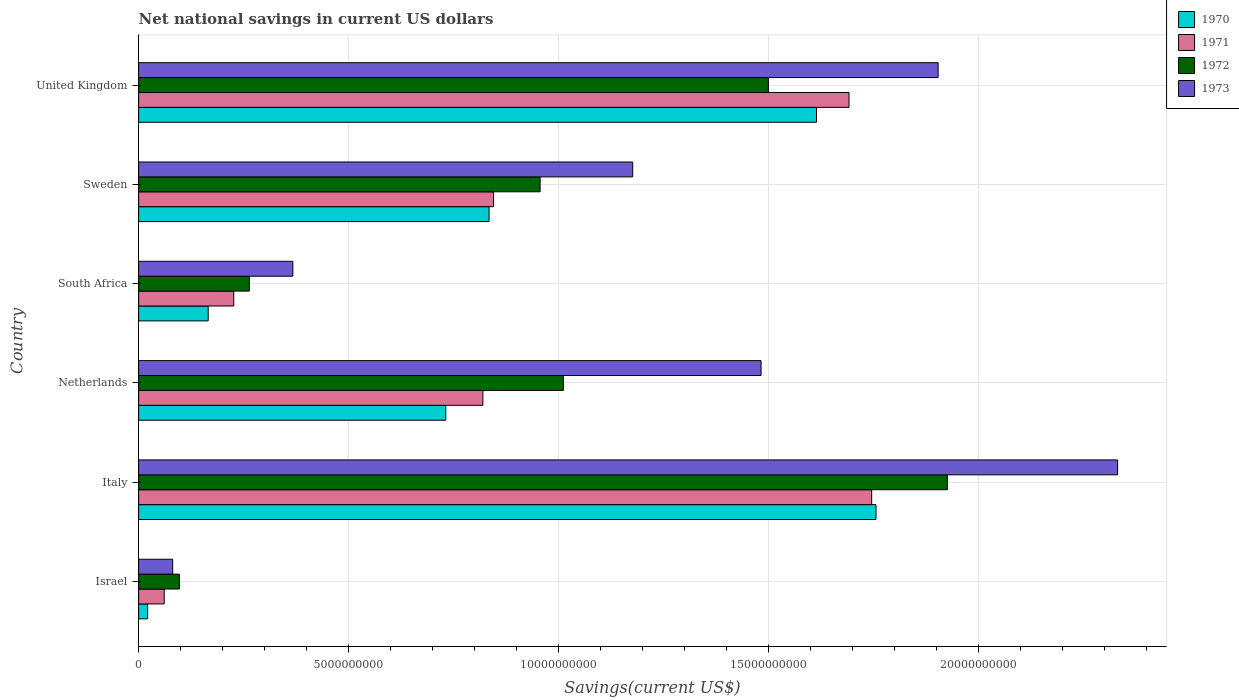How many different coloured bars are there?
Your answer should be compact. 4. How many bars are there on the 1st tick from the bottom?
Provide a short and direct response. 4. In how many cases, is the number of bars for a given country not equal to the number of legend labels?
Offer a terse response. 0. What is the net national savings in 1971 in United Kingdom?
Keep it short and to the point. 1.69e+1. Across all countries, what is the maximum net national savings in 1973?
Make the answer very short. 2.33e+1. Across all countries, what is the minimum net national savings in 1971?
Your answer should be very brief. 6.09e+08. In which country was the net national savings in 1973 maximum?
Your response must be concise. Italy. What is the total net national savings in 1973 in the graph?
Ensure brevity in your answer.  7.34e+1. What is the difference between the net national savings in 1972 in Netherlands and that in United Kingdom?
Keep it short and to the point. -4.88e+09. What is the difference between the net national savings in 1970 in Sweden and the net national savings in 1971 in Israel?
Make the answer very short. 7.73e+09. What is the average net national savings in 1973 per country?
Your answer should be very brief. 1.22e+1. What is the difference between the net national savings in 1972 and net national savings in 1971 in Israel?
Make the answer very short. 3.62e+08. In how many countries, is the net national savings in 1973 greater than 22000000000 US$?
Your answer should be compact. 1. What is the ratio of the net national savings in 1973 in Italy to that in Sweden?
Give a very brief answer. 1.98. Is the net national savings in 1973 in South Africa less than that in United Kingdom?
Provide a succinct answer. Yes. What is the difference between the highest and the second highest net national savings in 1971?
Provide a succinct answer. 5.40e+08. What is the difference between the highest and the lowest net national savings in 1970?
Offer a terse response. 1.73e+1. In how many countries, is the net national savings in 1972 greater than the average net national savings in 1972 taken over all countries?
Provide a short and direct response. 3. What does the 2nd bar from the top in Netherlands represents?
Provide a succinct answer. 1972. What does the 3rd bar from the bottom in Sweden represents?
Give a very brief answer. 1972. How many countries are there in the graph?
Give a very brief answer. 6. What is the difference between two consecutive major ticks on the X-axis?
Make the answer very short. 5.00e+09. Does the graph contain grids?
Make the answer very short. Yes. How are the legend labels stacked?
Keep it short and to the point. Vertical. What is the title of the graph?
Ensure brevity in your answer.  Net national savings in current US dollars. What is the label or title of the X-axis?
Offer a terse response. Savings(current US$). What is the label or title of the Y-axis?
Provide a succinct answer. Country. What is the Savings(current US$) in 1970 in Israel?
Keep it short and to the point. 2.15e+08. What is the Savings(current US$) of 1971 in Israel?
Provide a succinct answer. 6.09e+08. What is the Savings(current US$) of 1972 in Israel?
Give a very brief answer. 9.71e+08. What is the Savings(current US$) in 1973 in Israel?
Your answer should be compact. 8.11e+08. What is the Savings(current US$) in 1970 in Italy?
Provide a short and direct response. 1.76e+1. What is the Savings(current US$) of 1971 in Italy?
Keep it short and to the point. 1.75e+1. What is the Savings(current US$) in 1972 in Italy?
Give a very brief answer. 1.93e+1. What is the Savings(current US$) in 1973 in Italy?
Give a very brief answer. 2.33e+1. What is the Savings(current US$) in 1970 in Netherlands?
Make the answer very short. 7.31e+09. What is the Savings(current US$) of 1971 in Netherlands?
Make the answer very short. 8.20e+09. What is the Savings(current US$) in 1972 in Netherlands?
Provide a succinct answer. 1.01e+1. What is the Savings(current US$) in 1973 in Netherlands?
Provide a short and direct response. 1.48e+1. What is the Savings(current US$) in 1970 in South Africa?
Your response must be concise. 1.66e+09. What is the Savings(current US$) in 1971 in South Africa?
Offer a terse response. 2.27e+09. What is the Savings(current US$) in 1972 in South Africa?
Provide a short and direct response. 2.64e+09. What is the Savings(current US$) in 1973 in South Africa?
Offer a very short reply. 3.67e+09. What is the Savings(current US$) of 1970 in Sweden?
Ensure brevity in your answer.  8.34e+09. What is the Savings(current US$) in 1971 in Sweden?
Keep it short and to the point. 8.45e+09. What is the Savings(current US$) in 1972 in Sweden?
Offer a terse response. 9.56e+09. What is the Savings(current US$) of 1973 in Sweden?
Your answer should be compact. 1.18e+1. What is the Savings(current US$) of 1970 in United Kingdom?
Provide a succinct answer. 1.61e+1. What is the Savings(current US$) of 1971 in United Kingdom?
Provide a short and direct response. 1.69e+1. What is the Savings(current US$) of 1972 in United Kingdom?
Provide a short and direct response. 1.50e+1. What is the Savings(current US$) in 1973 in United Kingdom?
Your answer should be very brief. 1.90e+1. Across all countries, what is the maximum Savings(current US$) of 1970?
Ensure brevity in your answer.  1.76e+1. Across all countries, what is the maximum Savings(current US$) in 1971?
Your answer should be compact. 1.75e+1. Across all countries, what is the maximum Savings(current US$) of 1972?
Keep it short and to the point. 1.93e+1. Across all countries, what is the maximum Savings(current US$) in 1973?
Keep it short and to the point. 2.33e+1. Across all countries, what is the minimum Savings(current US$) in 1970?
Offer a very short reply. 2.15e+08. Across all countries, what is the minimum Savings(current US$) in 1971?
Ensure brevity in your answer.  6.09e+08. Across all countries, what is the minimum Savings(current US$) of 1972?
Your response must be concise. 9.71e+08. Across all countries, what is the minimum Savings(current US$) of 1973?
Provide a succinct answer. 8.11e+08. What is the total Savings(current US$) of 1970 in the graph?
Provide a short and direct response. 5.12e+1. What is the total Savings(current US$) in 1971 in the graph?
Make the answer very short. 5.39e+1. What is the total Savings(current US$) of 1972 in the graph?
Your response must be concise. 5.75e+1. What is the total Savings(current US$) in 1973 in the graph?
Keep it short and to the point. 7.34e+1. What is the difference between the Savings(current US$) in 1970 in Israel and that in Italy?
Your answer should be very brief. -1.73e+1. What is the difference between the Savings(current US$) in 1971 in Israel and that in Italy?
Keep it short and to the point. -1.68e+1. What is the difference between the Savings(current US$) in 1972 in Israel and that in Italy?
Your answer should be compact. -1.83e+1. What is the difference between the Savings(current US$) of 1973 in Israel and that in Italy?
Provide a succinct answer. -2.25e+1. What is the difference between the Savings(current US$) in 1970 in Israel and that in Netherlands?
Ensure brevity in your answer.  -7.10e+09. What is the difference between the Savings(current US$) in 1971 in Israel and that in Netherlands?
Give a very brief answer. -7.59e+09. What is the difference between the Savings(current US$) in 1972 in Israel and that in Netherlands?
Your answer should be compact. -9.14e+09. What is the difference between the Savings(current US$) of 1973 in Israel and that in Netherlands?
Your answer should be compact. -1.40e+1. What is the difference between the Savings(current US$) of 1970 in Israel and that in South Africa?
Provide a short and direct response. -1.44e+09. What is the difference between the Savings(current US$) in 1971 in Israel and that in South Africa?
Provide a short and direct response. -1.66e+09. What is the difference between the Savings(current US$) of 1972 in Israel and that in South Africa?
Provide a succinct answer. -1.66e+09. What is the difference between the Savings(current US$) in 1973 in Israel and that in South Africa?
Your response must be concise. -2.86e+09. What is the difference between the Savings(current US$) in 1970 in Israel and that in Sweden?
Your answer should be very brief. -8.13e+09. What is the difference between the Savings(current US$) in 1971 in Israel and that in Sweden?
Your answer should be very brief. -7.84e+09. What is the difference between the Savings(current US$) of 1972 in Israel and that in Sweden?
Provide a short and direct response. -8.59e+09. What is the difference between the Savings(current US$) of 1973 in Israel and that in Sweden?
Your response must be concise. -1.10e+1. What is the difference between the Savings(current US$) in 1970 in Israel and that in United Kingdom?
Offer a terse response. -1.59e+1. What is the difference between the Savings(current US$) in 1971 in Israel and that in United Kingdom?
Ensure brevity in your answer.  -1.63e+1. What is the difference between the Savings(current US$) in 1972 in Israel and that in United Kingdom?
Offer a very short reply. -1.40e+1. What is the difference between the Savings(current US$) in 1973 in Israel and that in United Kingdom?
Offer a terse response. -1.82e+1. What is the difference between the Savings(current US$) in 1970 in Italy and that in Netherlands?
Provide a succinct answer. 1.02e+1. What is the difference between the Savings(current US$) of 1971 in Italy and that in Netherlands?
Your response must be concise. 9.26e+09. What is the difference between the Savings(current US$) in 1972 in Italy and that in Netherlands?
Provide a short and direct response. 9.14e+09. What is the difference between the Savings(current US$) in 1973 in Italy and that in Netherlands?
Keep it short and to the point. 8.49e+09. What is the difference between the Savings(current US$) of 1970 in Italy and that in South Africa?
Your answer should be very brief. 1.59e+1. What is the difference between the Savings(current US$) of 1971 in Italy and that in South Africa?
Your response must be concise. 1.52e+1. What is the difference between the Savings(current US$) of 1972 in Italy and that in South Africa?
Ensure brevity in your answer.  1.66e+1. What is the difference between the Savings(current US$) in 1973 in Italy and that in South Africa?
Give a very brief answer. 1.96e+1. What is the difference between the Savings(current US$) of 1970 in Italy and that in Sweden?
Give a very brief answer. 9.21e+09. What is the difference between the Savings(current US$) of 1971 in Italy and that in Sweden?
Make the answer very short. 9.00e+09. What is the difference between the Savings(current US$) in 1972 in Italy and that in Sweden?
Give a very brief answer. 9.70e+09. What is the difference between the Savings(current US$) of 1973 in Italy and that in Sweden?
Offer a terse response. 1.15e+1. What is the difference between the Savings(current US$) in 1970 in Italy and that in United Kingdom?
Keep it short and to the point. 1.42e+09. What is the difference between the Savings(current US$) in 1971 in Italy and that in United Kingdom?
Your response must be concise. 5.40e+08. What is the difference between the Savings(current US$) in 1972 in Italy and that in United Kingdom?
Make the answer very short. 4.26e+09. What is the difference between the Savings(current US$) of 1973 in Italy and that in United Kingdom?
Your response must be concise. 4.27e+09. What is the difference between the Savings(current US$) of 1970 in Netherlands and that in South Africa?
Keep it short and to the point. 5.66e+09. What is the difference between the Savings(current US$) of 1971 in Netherlands and that in South Africa?
Keep it short and to the point. 5.93e+09. What is the difference between the Savings(current US$) of 1972 in Netherlands and that in South Africa?
Give a very brief answer. 7.48e+09. What is the difference between the Savings(current US$) in 1973 in Netherlands and that in South Africa?
Your response must be concise. 1.11e+1. What is the difference between the Savings(current US$) in 1970 in Netherlands and that in Sweden?
Your answer should be very brief. -1.03e+09. What is the difference between the Savings(current US$) in 1971 in Netherlands and that in Sweden?
Give a very brief answer. -2.53e+08. What is the difference between the Savings(current US$) in 1972 in Netherlands and that in Sweden?
Your answer should be compact. 5.54e+08. What is the difference between the Savings(current US$) of 1973 in Netherlands and that in Sweden?
Provide a succinct answer. 3.06e+09. What is the difference between the Savings(current US$) in 1970 in Netherlands and that in United Kingdom?
Your answer should be compact. -8.83e+09. What is the difference between the Savings(current US$) of 1971 in Netherlands and that in United Kingdom?
Provide a succinct answer. -8.72e+09. What is the difference between the Savings(current US$) in 1972 in Netherlands and that in United Kingdom?
Provide a short and direct response. -4.88e+09. What is the difference between the Savings(current US$) in 1973 in Netherlands and that in United Kingdom?
Ensure brevity in your answer.  -4.22e+09. What is the difference between the Savings(current US$) in 1970 in South Africa and that in Sweden?
Offer a terse response. -6.69e+09. What is the difference between the Savings(current US$) of 1971 in South Africa and that in Sweden?
Give a very brief answer. -6.18e+09. What is the difference between the Savings(current US$) in 1972 in South Africa and that in Sweden?
Keep it short and to the point. -6.92e+09. What is the difference between the Savings(current US$) in 1973 in South Africa and that in Sweden?
Ensure brevity in your answer.  -8.09e+09. What is the difference between the Savings(current US$) of 1970 in South Africa and that in United Kingdom?
Ensure brevity in your answer.  -1.45e+1. What is the difference between the Savings(current US$) of 1971 in South Africa and that in United Kingdom?
Offer a very short reply. -1.46e+1. What is the difference between the Savings(current US$) in 1972 in South Africa and that in United Kingdom?
Provide a short and direct response. -1.24e+1. What is the difference between the Savings(current US$) in 1973 in South Africa and that in United Kingdom?
Make the answer very short. -1.54e+1. What is the difference between the Savings(current US$) in 1970 in Sweden and that in United Kingdom?
Provide a short and direct response. -7.80e+09. What is the difference between the Savings(current US$) of 1971 in Sweden and that in United Kingdom?
Keep it short and to the point. -8.46e+09. What is the difference between the Savings(current US$) in 1972 in Sweden and that in United Kingdom?
Your answer should be compact. -5.43e+09. What is the difference between the Savings(current US$) of 1973 in Sweden and that in United Kingdom?
Your response must be concise. -7.27e+09. What is the difference between the Savings(current US$) in 1970 in Israel and the Savings(current US$) in 1971 in Italy?
Your response must be concise. -1.72e+1. What is the difference between the Savings(current US$) in 1970 in Israel and the Savings(current US$) in 1972 in Italy?
Your answer should be compact. -1.90e+1. What is the difference between the Savings(current US$) in 1970 in Israel and the Savings(current US$) in 1973 in Italy?
Your answer should be very brief. -2.31e+1. What is the difference between the Savings(current US$) of 1971 in Israel and the Savings(current US$) of 1972 in Italy?
Provide a short and direct response. -1.86e+1. What is the difference between the Savings(current US$) of 1971 in Israel and the Savings(current US$) of 1973 in Italy?
Give a very brief answer. -2.27e+1. What is the difference between the Savings(current US$) of 1972 in Israel and the Savings(current US$) of 1973 in Italy?
Keep it short and to the point. -2.23e+1. What is the difference between the Savings(current US$) of 1970 in Israel and the Savings(current US$) of 1971 in Netherlands?
Make the answer very short. -7.98e+09. What is the difference between the Savings(current US$) in 1970 in Israel and the Savings(current US$) in 1972 in Netherlands?
Provide a succinct answer. -9.90e+09. What is the difference between the Savings(current US$) in 1970 in Israel and the Savings(current US$) in 1973 in Netherlands?
Offer a terse response. -1.46e+1. What is the difference between the Savings(current US$) of 1971 in Israel and the Savings(current US$) of 1972 in Netherlands?
Your response must be concise. -9.50e+09. What is the difference between the Savings(current US$) in 1971 in Israel and the Savings(current US$) in 1973 in Netherlands?
Give a very brief answer. -1.42e+1. What is the difference between the Savings(current US$) of 1972 in Israel and the Savings(current US$) of 1973 in Netherlands?
Offer a very short reply. -1.38e+1. What is the difference between the Savings(current US$) in 1970 in Israel and the Savings(current US$) in 1971 in South Africa?
Keep it short and to the point. -2.05e+09. What is the difference between the Savings(current US$) of 1970 in Israel and the Savings(current US$) of 1972 in South Africa?
Your answer should be very brief. -2.42e+09. What is the difference between the Savings(current US$) of 1970 in Israel and the Savings(current US$) of 1973 in South Africa?
Provide a succinct answer. -3.46e+09. What is the difference between the Savings(current US$) of 1971 in Israel and the Savings(current US$) of 1972 in South Africa?
Ensure brevity in your answer.  -2.03e+09. What is the difference between the Savings(current US$) in 1971 in Israel and the Savings(current US$) in 1973 in South Africa?
Your response must be concise. -3.06e+09. What is the difference between the Savings(current US$) of 1972 in Israel and the Savings(current US$) of 1973 in South Africa?
Your answer should be very brief. -2.70e+09. What is the difference between the Savings(current US$) of 1970 in Israel and the Savings(current US$) of 1971 in Sweden?
Give a very brief answer. -8.23e+09. What is the difference between the Savings(current US$) in 1970 in Israel and the Savings(current US$) in 1972 in Sweden?
Make the answer very short. -9.34e+09. What is the difference between the Savings(current US$) of 1970 in Israel and the Savings(current US$) of 1973 in Sweden?
Provide a short and direct response. -1.15e+1. What is the difference between the Savings(current US$) in 1971 in Israel and the Savings(current US$) in 1972 in Sweden?
Offer a very short reply. -8.95e+09. What is the difference between the Savings(current US$) in 1971 in Israel and the Savings(current US$) in 1973 in Sweden?
Give a very brief answer. -1.12e+1. What is the difference between the Savings(current US$) in 1972 in Israel and the Savings(current US$) in 1973 in Sweden?
Give a very brief answer. -1.08e+1. What is the difference between the Savings(current US$) of 1970 in Israel and the Savings(current US$) of 1971 in United Kingdom?
Provide a short and direct response. -1.67e+1. What is the difference between the Savings(current US$) of 1970 in Israel and the Savings(current US$) of 1972 in United Kingdom?
Give a very brief answer. -1.48e+1. What is the difference between the Savings(current US$) of 1970 in Israel and the Savings(current US$) of 1973 in United Kingdom?
Make the answer very short. -1.88e+1. What is the difference between the Savings(current US$) of 1971 in Israel and the Savings(current US$) of 1972 in United Kingdom?
Make the answer very short. -1.44e+1. What is the difference between the Savings(current US$) of 1971 in Israel and the Savings(current US$) of 1973 in United Kingdom?
Your answer should be compact. -1.84e+1. What is the difference between the Savings(current US$) of 1972 in Israel and the Savings(current US$) of 1973 in United Kingdom?
Keep it short and to the point. -1.81e+1. What is the difference between the Savings(current US$) of 1970 in Italy and the Savings(current US$) of 1971 in Netherlands?
Keep it short and to the point. 9.36e+09. What is the difference between the Savings(current US$) of 1970 in Italy and the Savings(current US$) of 1972 in Netherlands?
Your answer should be very brief. 7.44e+09. What is the difference between the Savings(current US$) of 1970 in Italy and the Savings(current US$) of 1973 in Netherlands?
Ensure brevity in your answer.  2.74e+09. What is the difference between the Savings(current US$) of 1971 in Italy and the Savings(current US$) of 1972 in Netherlands?
Make the answer very short. 7.34e+09. What is the difference between the Savings(current US$) of 1971 in Italy and the Savings(current US$) of 1973 in Netherlands?
Keep it short and to the point. 2.63e+09. What is the difference between the Savings(current US$) of 1972 in Italy and the Savings(current US$) of 1973 in Netherlands?
Make the answer very short. 4.44e+09. What is the difference between the Savings(current US$) of 1970 in Italy and the Savings(current US$) of 1971 in South Africa?
Give a very brief answer. 1.53e+1. What is the difference between the Savings(current US$) of 1970 in Italy and the Savings(current US$) of 1972 in South Africa?
Keep it short and to the point. 1.49e+1. What is the difference between the Savings(current US$) of 1970 in Italy and the Savings(current US$) of 1973 in South Africa?
Give a very brief answer. 1.39e+1. What is the difference between the Savings(current US$) in 1971 in Italy and the Savings(current US$) in 1972 in South Africa?
Offer a terse response. 1.48e+1. What is the difference between the Savings(current US$) in 1971 in Italy and the Savings(current US$) in 1973 in South Africa?
Your answer should be compact. 1.38e+1. What is the difference between the Savings(current US$) of 1972 in Italy and the Savings(current US$) of 1973 in South Africa?
Provide a succinct answer. 1.56e+1. What is the difference between the Savings(current US$) of 1970 in Italy and the Savings(current US$) of 1971 in Sweden?
Give a very brief answer. 9.11e+09. What is the difference between the Savings(current US$) of 1970 in Italy and the Savings(current US$) of 1972 in Sweden?
Make the answer very short. 8.00e+09. What is the difference between the Savings(current US$) of 1970 in Italy and the Savings(current US$) of 1973 in Sweden?
Keep it short and to the point. 5.79e+09. What is the difference between the Savings(current US$) in 1971 in Italy and the Savings(current US$) in 1972 in Sweden?
Your answer should be compact. 7.89e+09. What is the difference between the Savings(current US$) of 1971 in Italy and the Savings(current US$) of 1973 in Sweden?
Your answer should be compact. 5.69e+09. What is the difference between the Savings(current US$) of 1972 in Italy and the Savings(current US$) of 1973 in Sweden?
Offer a very short reply. 7.49e+09. What is the difference between the Savings(current US$) in 1970 in Italy and the Savings(current US$) in 1971 in United Kingdom?
Offer a very short reply. 6.43e+08. What is the difference between the Savings(current US$) in 1970 in Italy and the Savings(current US$) in 1972 in United Kingdom?
Offer a very short reply. 2.56e+09. What is the difference between the Savings(current US$) of 1970 in Italy and the Savings(current US$) of 1973 in United Kingdom?
Provide a short and direct response. -1.48e+09. What is the difference between the Savings(current US$) in 1971 in Italy and the Savings(current US$) in 1972 in United Kingdom?
Offer a terse response. 2.46e+09. What is the difference between the Savings(current US$) in 1971 in Italy and the Savings(current US$) in 1973 in United Kingdom?
Your answer should be compact. -1.58e+09. What is the difference between the Savings(current US$) of 1972 in Italy and the Savings(current US$) of 1973 in United Kingdom?
Ensure brevity in your answer.  2.20e+08. What is the difference between the Savings(current US$) in 1970 in Netherlands and the Savings(current US$) in 1971 in South Africa?
Your answer should be compact. 5.05e+09. What is the difference between the Savings(current US$) in 1970 in Netherlands and the Savings(current US$) in 1972 in South Africa?
Ensure brevity in your answer.  4.68e+09. What is the difference between the Savings(current US$) of 1970 in Netherlands and the Savings(current US$) of 1973 in South Africa?
Keep it short and to the point. 3.64e+09. What is the difference between the Savings(current US$) of 1971 in Netherlands and the Savings(current US$) of 1972 in South Africa?
Provide a succinct answer. 5.56e+09. What is the difference between the Savings(current US$) of 1971 in Netherlands and the Savings(current US$) of 1973 in South Africa?
Give a very brief answer. 4.52e+09. What is the difference between the Savings(current US$) of 1972 in Netherlands and the Savings(current US$) of 1973 in South Africa?
Your answer should be very brief. 6.44e+09. What is the difference between the Savings(current US$) in 1970 in Netherlands and the Savings(current US$) in 1971 in Sweden?
Keep it short and to the point. -1.14e+09. What is the difference between the Savings(current US$) of 1970 in Netherlands and the Savings(current US$) of 1972 in Sweden?
Your response must be concise. -2.25e+09. What is the difference between the Savings(current US$) in 1970 in Netherlands and the Savings(current US$) in 1973 in Sweden?
Provide a succinct answer. -4.45e+09. What is the difference between the Savings(current US$) of 1971 in Netherlands and the Savings(current US$) of 1972 in Sweden?
Give a very brief answer. -1.36e+09. What is the difference between the Savings(current US$) in 1971 in Netherlands and the Savings(current US$) in 1973 in Sweden?
Give a very brief answer. -3.57e+09. What is the difference between the Savings(current US$) of 1972 in Netherlands and the Savings(current US$) of 1973 in Sweden?
Give a very brief answer. -1.65e+09. What is the difference between the Savings(current US$) in 1970 in Netherlands and the Savings(current US$) in 1971 in United Kingdom?
Your answer should be compact. -9.60e+09. What is the difference between the Savings(current US$) in 1970 in Netherlands and the Savings(current US$) in 1972 in United Kingdom?
Ensure brevity in your answer.  -7.68e+09. What is the difference between the Savings(current US$) in 1970 in Netherlands and the Savings(current US$) in 1973 in United Kingdom?
Provide a short and direct response. -1.17e+1. What is the difference between the Savings(current US$) in 1971 in Netherlands and the Savings(current US$) in 1972 in United Kingdom?
Offer a very short reply. -6.80e+09. What is the difference between the Savings(current US$) of 1971 in Netherlands and the Savings(current US$) of 1973 in United Kingdom?
Provide a short and direct response. -1.08e+1. What is the difference between the Savings(current US$) of 1972 in Netherlands and the Savings(current US$) of 1973 in United Kingdom?
Ensure brevity in your answer.  -8.92e+09. What is the difference between the Savings(current US$) in 1970 in South Africa and the Savings(current US$) in 1971 in Sweden?
Give a very brief answer. -6.79e+09. What is the difference between the Savings(current US$) in 1970 in South Africa and the Savings(current US$) in 1972 in Sweden?
Give a very brief answer. -7.90e+09. What is the difference between the Savings(current US$) of 1970 in South Africa and the Savings(current US$) of 1973 in Sweden?
Your answer should be very brief. -1.01e+1. What is the difference between the Savings(current US$) in 1971 in South Africa and the Savings(current US$) in 1972 in Sweden?
Offer a very short reply. -7.29e+09. What is the difference between the Savings(current US$) of 1971 in South Africa and the Savings(current US$) of 1973 in Sweden?
Provide a short and direct response. -9.50e+09. What is the difference between the Savings(current US$) of 1972 in South Africa and the Savings(current US$) of 1973 in Sweden?
Your answer should be compact. -9.13e+09. What is the difference between the Savings(current US$) in 1970 in South Africa and the Savings(current US$) in 1971 in United Kingdom?
Offer a terse response. -1.53e+1. What is the difference between the Savings(current US$) in 1970 in South Africa and the Savings(current US$) in 1972 in United Kingdom?
Provide a short and direct response. -1.33e+1. What is the difference between the Savings(current US$) in 1970 in South Africa and the Savings(current US$) in 1973 in United Kingdom?
Make the answer very short. -1.74e+1. What is the difference between the Savings(current US$) of 1971 in South Africa and the Savings(current US$) of 1972 in United Kingdom?
Offer a very short reply. -1.27e+1. What is the difference between the Savings(current US$) of 1971 in South Africa and the Savings(current US$) of 1973 in United Kingdom?
Offer a very short reply. -1.68e+1. What is the difference between the Savings(current US$) of 1972 in South Africa and the Savings(current US$) of 1973 in United Kingdom?
Provide a succinct answer. -1.64e+1. What is the difference between the Savings(current US$) in 1970 in Sweden and the Savings(current US$) in 1971 in United Kingdom?
Provide a succinct answer. -8.57e+09. What is the difference between the Savings(current US$) in 1970 in Sweden and the Savings(current US$) in 1972 in United Kingdom?
Your response must be concise. -6.65e+09. What is the difference between the Savings(current US$) of 1970 in Sweden and the Savings(current US$) of 1973 in United Kingdom?
Provide a succinct answer. -1.07e+1. What is the difference between the Savings(current US$) of 1971 in Sweden and the Savings(current US$) of 1972 in United Kingdom?
Ensure brevity in your answer.  -6.54e+09. What is the difference between the Savings(current US$) in 1971 in Sweden and the Savings(current US$) in 1973 in United Kingdom?
Ensure brevity in your answer.  -1.06e+1. What is the difference between the Savings(current US$) in 1972 in Sweden and the Savings(current US$) in 1973 in United Kingdom?
Offer a terse response. -9.48e+09. What is the average Savings(current US$) in 1970 per country?
Offer a very short reply. 8.54e+09. What is the average Savings(current US$) of 1971 per country?
Your response must be concise. 8.98e+09. What is the average Savings(current US$) of 1972 per country?
Give a very brief answer. 9.59e+09. What is the average Savings(current US$) of 1973 per country?
Make the answer very short. 1.22e+1. What is the difference between the Savings(current US$) of 1970 and Savings(current US$) of 1971 in Israel?
Your answer should be very brief. -3.94e+08. What is the difference between the Savings(current US$) of 1970 and Savings(current US$) of 1972 in Israel?
Keep it short and to the point. -7.56e+08. What is the difference between the Savings(current US$) of 1970 and Savings(current US$) of 1973 in Israel?
Make the answer very short. -5.96e+08. What is the difference between the Savings(current US$) in 1971 and Savings(current US$) in 1972 in Israel?
Make the answer very short. -3.62e+08. What is the difference between the Savings(current US$) of 1971 and Savings(current US$) of 1973 in Israel?
Give a very brief answer. -2.02e+08. What is the difference between the Savings(current US$) in 1972 and Savings(current US$) in 1973 in Israel?
Your response must be concise. 1.60e+08. What is the difference between the Savings(current US$) of 1970 and Savings(current US$) of 1971 in Italy?
Offer a very short reply. 1.03e+08. What is the difference between the Savings(current US$) of 1970 and Savings(current US$) of 1972 in Italy?
Provide a succinct answer. -1.70e+09. What is the difference between the Savings(current US$) of 1970 and Savings(current US$) of 1973 in Italy?
Offer a terse response. -5.75e+09. What is the difference between the Savings(current US$) in 1971 and Savings(current US$) in 1972 in Italy?
Make the answer very short. -1.80e+09. What is the difference between the Savings(current US$) of 1971 and Savings(current US$) of 1973 in Italy?
Ensure brevity in your answer.  -5.86e+09. What is the difference between the Savings(current US$) in 1972 and Savings(current US$) in 1973 in Italy?
Your answer should be very brief. -4.05e+09. What is the difference between the Savings(current US$) of 1970 and Savings(current US$) of 1971 in Netherlands?
Make the answer very short. -8.83e+08. What is the difference between the Savings(current US$) in 1970 and Savings(current US$) in 1972 in Netherlands?
Offer a terse response. -2.80e+09. What is the difference between the Savings(current US$) in 1970 and Savings(current US$) in 1973 in Netherlands?
Offer a very short reply. -7.51e+09. What is the difference between the Savings(current US$) of 1971 and Savings(current US$) of 1972 in Netherlands?
Offer a terse response. -1.92e+09. What is the difference between the Savings(current US$) of 1971 and Savings(current US$) of 1973 in Netherlands?
Keep it short and to the point. -6.62e+09. What is the difference between the Savings(current US$) of 1972 and Savings(current US$) of 1973 in Netherlands?
Ensure brevity in your answer.  -4.71e+09. What is the difference between the Savings(current US$) in 1970 and Savings(current US$) in 1971 in South Africa?
Keep it short and to the point. -6.09e+08. What is the difference between the Savings(current US$) of 1970 and Savings(current US$) of 1972 in South Africa?
Keep it short and to the point. -9.79e+08. What is the difference between the Savings(current US$) of 1970 and Savings(current US$) of 1973 in South Africa?
Provide a short and direct response. -2.02e+09. What is the difference between the Savings(current US$) of 1971 and Savings(current US$) of 1972 in South Africa?
Your response must be concise. -3.70e+08. What is the difference between the Savings(current US$) of 1971 and Savings(current US$) of 1973 in South Africa?
Keep it short and to the point. -1.41e+09. What is the difference between the Savings(current US$) of 1972 and Savings(current US$) of 1973 in South Africa?
Provide a succinct answer. -1.04e+09. What is the difference between the Savings(current US$) in 1970 and Savings(current US$) in 1971 in Sweden?
Ensure brevity in your answer.  -1.07e+08. What is the difference between the Savings(current US$) in 1970 and Savings(current US$) in 1972 in Sweden?
Offer a very short reply. -1.22e+09. What is the difference between the Savings(current US$) of 1970 and Savings(current US$) of 1973 in Sweden?
Ensure brevity in your answer.  -3.42e+09. What is the difference between the Savings(current US$) of 1971 and Savings(current US$) of 1972 in Sweden?
Provide a succinct answer. -1.11e+09. What is the difference between the Savings(current US$) in 1971 and Savings(current US$) in 1973 in Sweden?
Your answer should be compact. -3.31e+09. What is the difference between the Savings(current US$) of 1972 and Savings(current US$) of 1973 in Sweden?
Give a very brief answer. -2.20e+09. What is the difference between the Savings(current US$) of 1970 and Savings(current US$) of 1971 in United Kingdom?
Offer a very short reply. -7.74e+08. What is the difference between the Savings(current US$) in 1970 and Savings(current US$) in 1972 in United Kingdom?
Provide a succinct answer. 1.15e+09. What is the difference between the Savings(current US$) of 1970 and Savings(current US$) of 1973 in United Kingdom?
Offer a very short reply. -2.90e+09. What is the difference between the Savings(current US$) of 1971 and Savings(current US$) of 1972 in United Kingdom?
Offer a very short reply. 1.92e+09. What is the difference between the Savings(current US$) in 1971 and Savings(current US$) in 1973 in United Kingdom?
Provide a short and direct response. -2.12e+09. What is the difference between the Savings(current US$) in 1972 and Savings(current US$) in 1973 in United Kingdom?
Offer a very short reply. -4.04e+09. What is the ratio of the Savings(current US$) in 1970 in Israel to that in Italy?
Make the answer very short. 0.01. What is the ratio of the Savings(current US$) of 1971 in Israel to that in Italy?
Your response must be concise. 0.03. What is the ratio of the Savings(current US$) of 1972 in Israel to that in Italy?
Ensure brevity in your answer.  0.05. What is the ratio of the Savings(current US$) of 1973 in Israel to that in Italy?
Provide a short and direct response. 0.03. What is the ratio of the Savings(current US$) in 1970 in Israel to that in Netherlands?
Offer a terse response. 0.03. What is the ratio of the Savings(current US$) of 1971 in Israel to that in Netherlands?
Keep it short and to the point. 0.07. What is the ratio of the Savings(current US$) of 1972 in Israel to that in Netherlands?
Make the answer very short. 0.1. What is the ratio of the Savings(current US$) in 1973 in Israel to that in Netherlands?
Your response must be concise. 0.05. What is the ratio of the Savings(current US$) in 1970 in Israel to that in South Africa?
Your response must be concise. 0.13. What is the ratio of the Savings(current US$) in 1971 in Israel to that in South Africa?
Provide a succinct answer. 0.27. What is the ratio of the Savings(current US$) in 1972 in Israel to that in South Africa?
Offer a very short reply. 0.37. What is the ratio of the Savings(current US$) in 1973 in Israel to that in South Africa?
Your answer should be compact. 0.22. What is the ratio of the Savings(current US$) in 1970 in Israel to that in Sweden?
Your answer should be very brief. 0.03. What is the ratio of the Savings(current US$) of 1971 in Israel to that in Sweden?
Your answer should be very brief. 0.07. What is the ratio of the Savings(current US$) in 1972 in Israel to that in Sweden?
Offer a terse response. 0.1. What is the ratio of the Savings(current US$) of 1973 in Israel to that in Sweden?
Keep it short and to the point. 0.07. What is the ratio of the Savings(current US$) in 1970 in Israel to that in United Kingdom?
Give a very brief answer. 0.01. What is the ratio of the Savings(current US$) of 1971 in Israel to that in United Kingdom?
Offer a very short reply. 0.04. What is the ratio of the Savings(current US$) in 1972 in Israel to that in United Kingdom?
Your answer should be very brief. 0.06. What is the ratio of the Savings(current US$) in 1973 in Israel to that in United Kingdom?
Make the answer very short. 0.04. What is the ratio of the Savings(current US$) of 1970 in Italy to that in Netherlands?
Your answer should be compact. 2.4. What is the ratio of the Savings(current US$) in 1971 in Italy to that in Netherlands?
Provide a short and direct response. 2.13. What is the ratio of the Savings(current US$) in 1972 in Italy to that in Netherlands?
Make the answer very short. 1.9. What is the ratio of the Savings(current US$) in 1973 in Italy to that in Netherlands?
Offer a very short reply. 1.57. What is the ratio of the Savings(current US$) of 1970 in Italy to that in South Africa?
Your answer should be compact. 10.6. What is the ratio of the Savings(current US$) of 1971 in Italy to that in South Africa?
Ensure brevity in your answer.  7.7. What is the ratio of the Savings(current US$) in 1972 in Italy to that in South Africa?
Your answer should be compact. 7.31. What is the ratio of the Savings(current US$) of 1973 in Italy to that in South Africa?
Provide a succinct answer. 6.35. What is the ratio of the Savings(current US$) in 1970 in Italy to that in Sweden?
Your answer should be very brief. 2.1. What is the ratio of the Savings(current US$) of 1971 in Italy to that in Sweden?
Your answer should be very brief. 2.07. What is the ratio of the Savings(current US$) in 1972 in Italy to that in Sweden?
Provide a short and direct response. 2.01. What is the ratio of the Savings(current US$) in 1973 in Italy to that in Sweden?
Provide a short and direct response. 1.98. What is the ratio of the Savings(current US$) of 1970 in Italy to that in United Kingdom?
Ensure brevity in your answer.  1.09. What is the ratio of the Savings(current US$) of 1971 in Italy to that in United Kingdom?
Ensure brevity in your answer.  1.03. What is the ratio of the Savings(current US$) of 1972 in Italy to that in United Kingdom?
Provide a succinct answer. 1.28. What is the ratio of the Savings(current US$) of 1973 in Italy to that in United Kingdom?
Give a very brief answer. 1.22. What is the ratio of the Savings(current US$) in 1970 in Netherlands to that in South Africa?
Ensure brevity in your answer.  4.42. What is the ratio of the Savings(current US$) in 1971 in Netherlands to that in South Africa?
Ensure brevity in your answer.  3.62. What is the ratio of the Savings(current US$) in 1972 in Netherlands to that in South Africa?
Provide a short and direct response. 3.84. What is the ratio of the Savings(current US$) in 1973 in Netherlands to that in South Africa?
Your answer should be compact. 4.04. What is the ratio of the Savings(current US$) of 1970 in Netherlands to that in Sweden?
Keep it short and to the point. 0.88. What is the ratio of the Savings(current US$) in 1972 in Netherlands to that in Sweden?
Offer a very short reply. 1.06. What is the ratio of the Savings(current US$) in 1973 in Netherlands to that in Sweden?
Your answer should be very brief. 1.26. What is the ratio of the Savings(current US$) in 1970 in Netherlands to that in United Kingdom?
Your answer should be very brief. 0.45. What is the ratio of the Savings(current US$) in 1971 in Netherlands to that in United Kingdom?
Offer a terse response. 0.48. What is the ratio of the Savings(current US$) of 1972 in Netherlands to that in United Kingdom?
Provide a short and direct response. 0.67. What is the ratio of the Savings(current US$) in 1973 in Netherlands to that in United Kingdom?
Your response must be concise. 0.78. What is the ratio of the Savings(current US$) in 1970 in South Africa to that in Sweden?
Make the answer very short. 0.2. What is the ratio of the Savings(current US$) of 1971 in South Africa to that in Sweden?
Your answer should be compact. 0.27. What is the ratio of the Savings(current US$) of 1972 in South Africa to that in Sweden?
Your answer should be very brief. 0.28. What is the ratio of the Savings(current US$) of 1973 in South Africa to that in Sweden?
Ensure brevity in your answer.  0.31. What is the ratio of the Savings(current US$) of 1970 in South Africa to that in United Kingdom?
Your response must be concise. 0.1. What is the ratio of the Savings(current US$) in 1971 in South Africa to that in United Kingdom?
Your response must be concise. 0.13. What is the ratio of the Savings(current US$) in 1972 in South Africa to that in United Kingdom?
Offer a terse response. 0.18. What is the ratio of the Savings(current US$) in 1973 in South Africa to that in United Kingdom?
Make the answer very short. 0.19. What is the ratio of the Savings(current US$) in 1970 in Sweden to that in United Kingdom?
Keep it short and to the point. 0.52. What is the ratio of the Savings(current US$) of 1971 in Sweden to that in United Kingdom?
Make the answer very short. 0.5. What is the ratio of the Savings(current US$) in 1972 in Sweden to that in United Kingdom?
Give a very brief answer. 0.64. What is the ratio of the Savings(current US$) of 1973 in Sweden to that in United Kingdom?
Provide a succinct answer. 0.62. What is the difference between the highest and the second highest Savings(current US$) of 1970?
Offer a terse response. 1.42e+09. What is the difference between the highest and the second highest Savings(current US$) of 1971?
Make the answer very short. 5.40e+08. What is the difference between the highest and the second highest Savings(current US$) of 1972?
Give a very brief answer. 4.26e+09. What is the difference between the highest and the second highest Savings(current US$) in 1973?
Offer a very short reply. 4.27e+09. What is the difference between the highest and the lowest Savings(current US$) of 1970?
Your answer should be very brief. 1.73e+1. What is the difference between the highest and the lowest Savings(current US$) in 1971?
Your answer should be very brief. 1.68e+1. What is the difference between the highest and the lowest Savings(current US$) of 1972?
Give a very brief answer. 1.83e+1. What is the difference between the highest and the lowest Savings(current US$) of 1973?
Make the answer very short. 2.25e+1. 